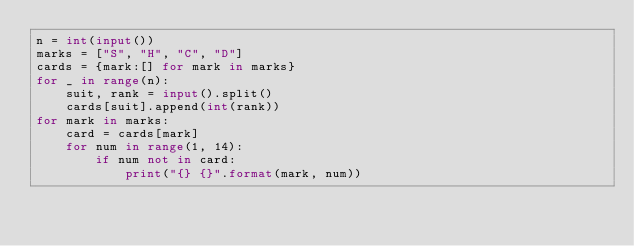<code> <loc_0><loc_0><loc_500><loc_500><_Python_>n = int(input())
marks = ["S", "H", "C", "D"]
cards = {mark:[] for mark in marks}
for _ in range(n):
    suit, rank = input().split()
    cards[suit].append(int(rank))
for mark in marks:
    card = cards[mark]
    for num in range(1, 14):
        if num not in card:
            print("{} {}".format(mark, num))
</code> 